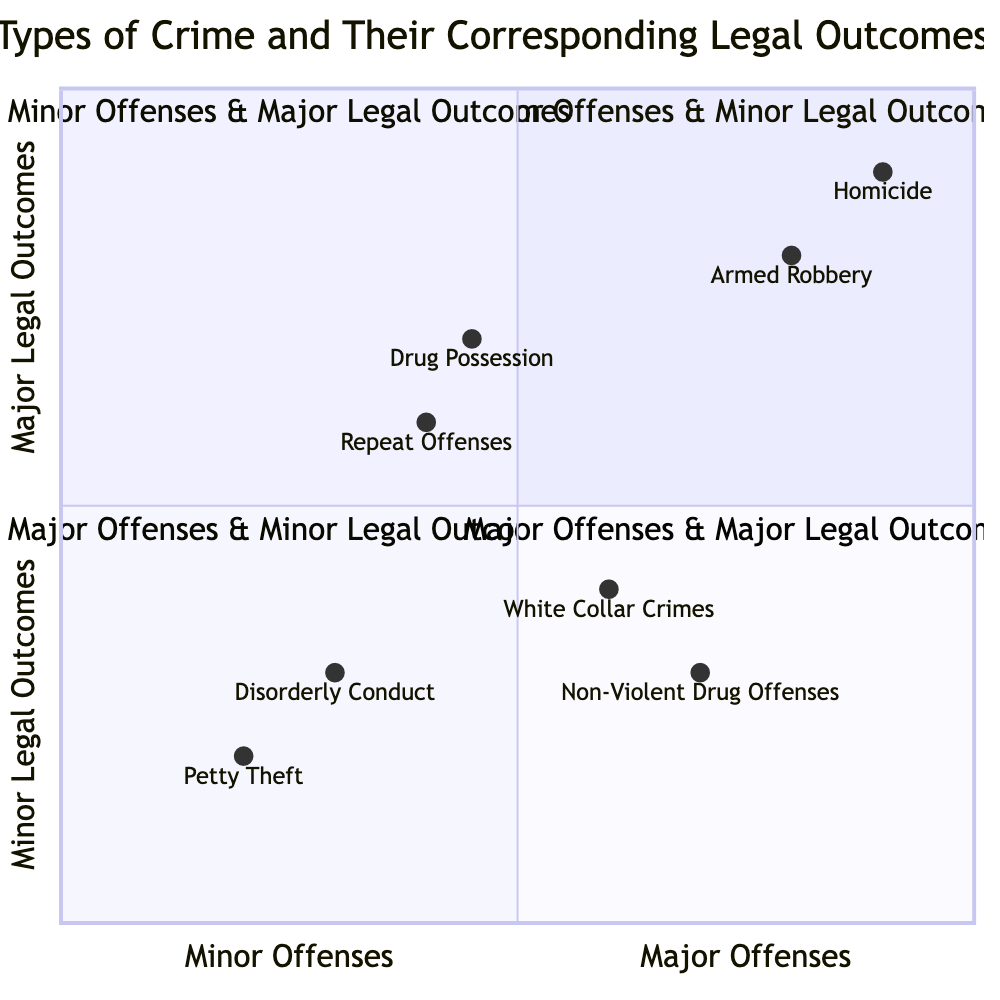What's located in the Minor Offenses & Minor Legal Outcomes quadrant? The Minor Offenses & Minor Legal Outcomes quadrant contains two types of crime: Petty Theft and Disorderly Conduct. Both these crimes result in lesser legal outcomes such as fines and community service.
Answer: Petty Theft, Disorderly Conduct How many types of crimes are there in the Major Offenses & Major Legal Outcomes quadrant? The Major Offenses & Major Legal Outcomes quadrant includes two types of crime: Homicide and Armed Robbery. Thus, there are two types of crimes in this quadrant.
Answer: 2 What legal outcome corresponds to Repeat Offenses? Repeat Offenses have multiple legal outcomes, which include increased fines, extended probation, and community service. By identifying the specific crime in the quadrant, we can determine these associated legal outcomes.
Answer: Increased Fines, Extended Probation, Community Service Which type of crime in the Major Offenses & Minor Legal Outcomes quadrant has fines as a legal outcome? The White Collar Crimes in the Major Offenses & Minor Legal Outcomes quadrant includes fines as part of its legal outcomes, which also includes restitution and short-term incarceration.
Answer: White Collar Crimes In which quadrant does Drug Possession (Small Amount) appear? Drug Possession (Small Amount) is found in the Minor Offenses & Major Legal Outcomes quadrant, where it is associated with legal outcomes like rehabilitation programs and probation.
Answer: Minor Offenses & Major Legal Outcomes How do the legal outcomes of armed robbery compare to non-violent drug offenses? Armed Robbery results in long-term imprisonment, while Non-Violent Drug Offenses lead to rehabilitation and probation. Therefore, the legal outcomes differ significantly in severity and type between these two crimes.
Answer: Armed Robbery: Long-term Imprisonment, Non-Violent Drug Offenses: Rehabilitation, Probation What type of crime is categorized under Major Offenses & Minor Legal Outcomes that involves intent to distribute? The type of crime categorized under Major Offenses & Minor Legal Outcomes that involves intent to distribute is Non-Violent Drug Offenses. This determination comes from evaluating the types of crimes listed within that specific quadrant.
Answer: Non-Violent Drug Offenses Which legal outcome is the most severe seen in the diagram? The most severe legal outcomes in the diagram include Life Imprisonment and the Death Penalty, both associated with Homicide in the Major Offenses & Major Legal Outcomes quadrant.
Answer: Life Imprisonment, Death Penalty 